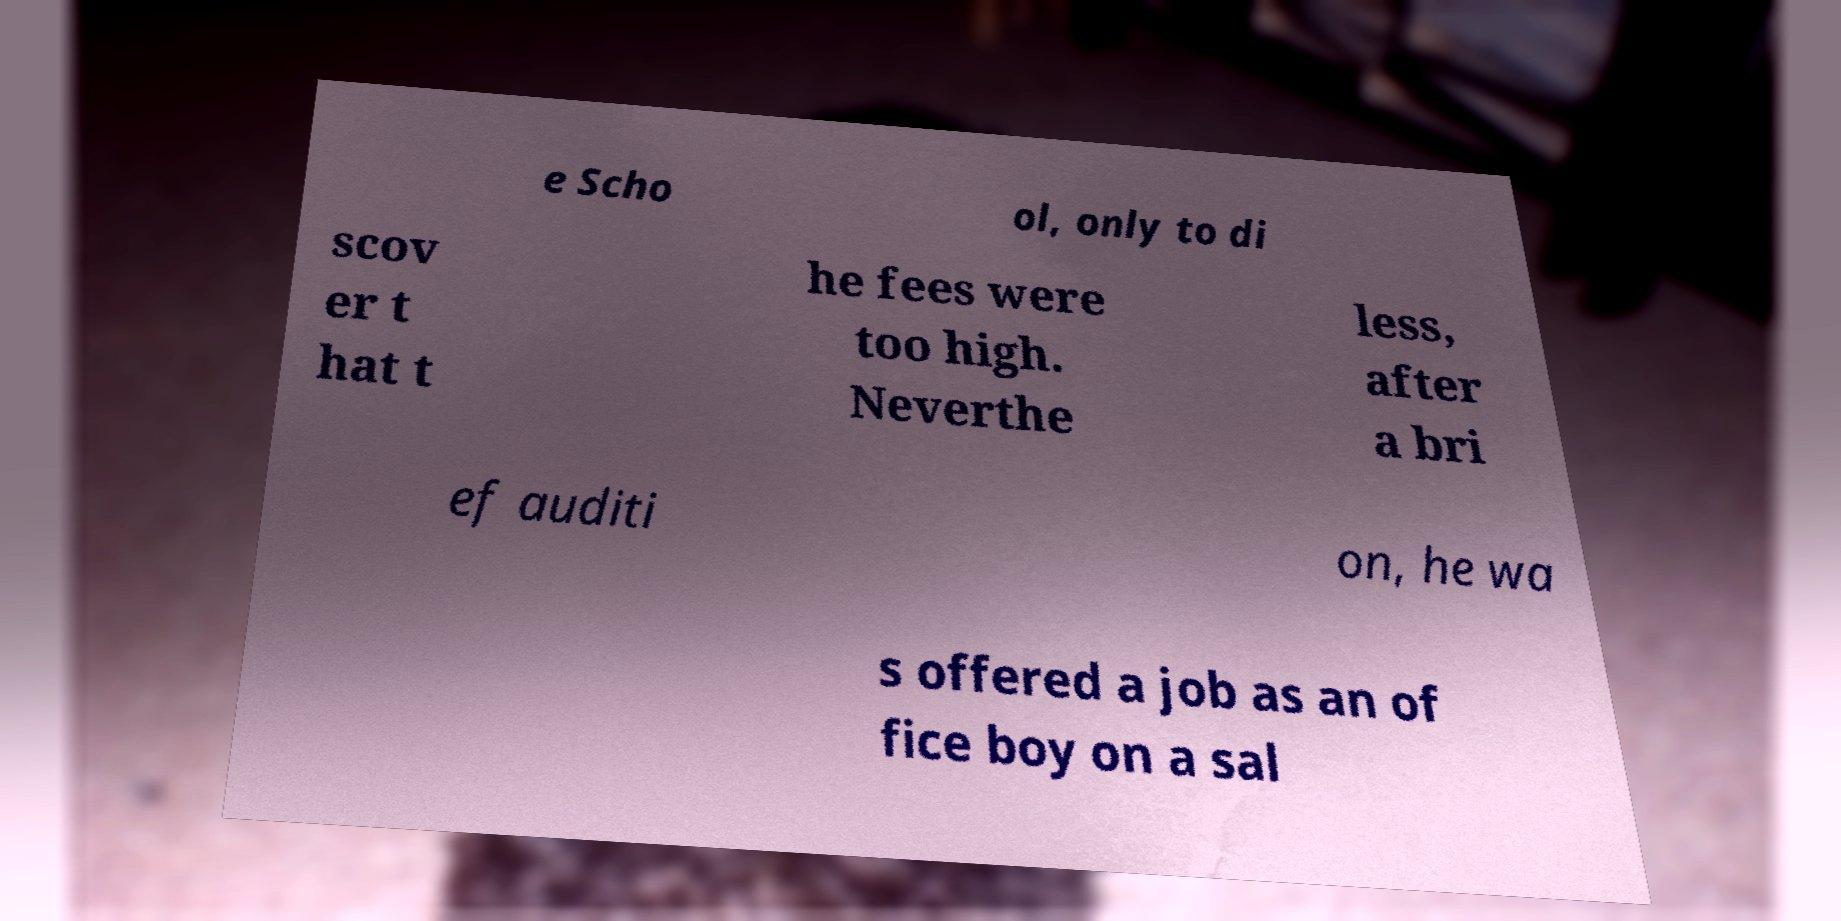Can you read and provide the text displayed in the image?This photo seems to have some interesting text. Can you extract and type it out for me? e Scho ol, only to di scov er t hat t he fees were too high. Neverthe less, after a bri ef auditi on, he wa s offered a job as an of fice boy on a sal 